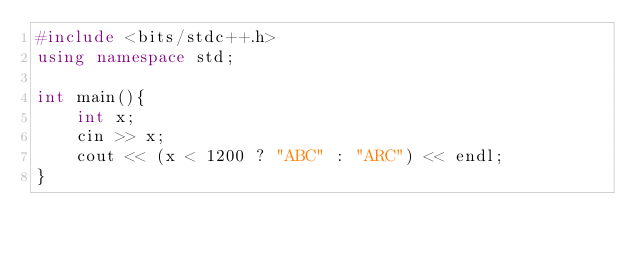Convert code to text. <code><loc_0><loc_0><loc_500><loc_500><_C++_>#include <bits/stdc++.h>
using namespace std;

int main(){
    int x;
    cin >> x;
    cout << (x < 1200 ? "ABC" : "ARC") << endl;
}</code> 